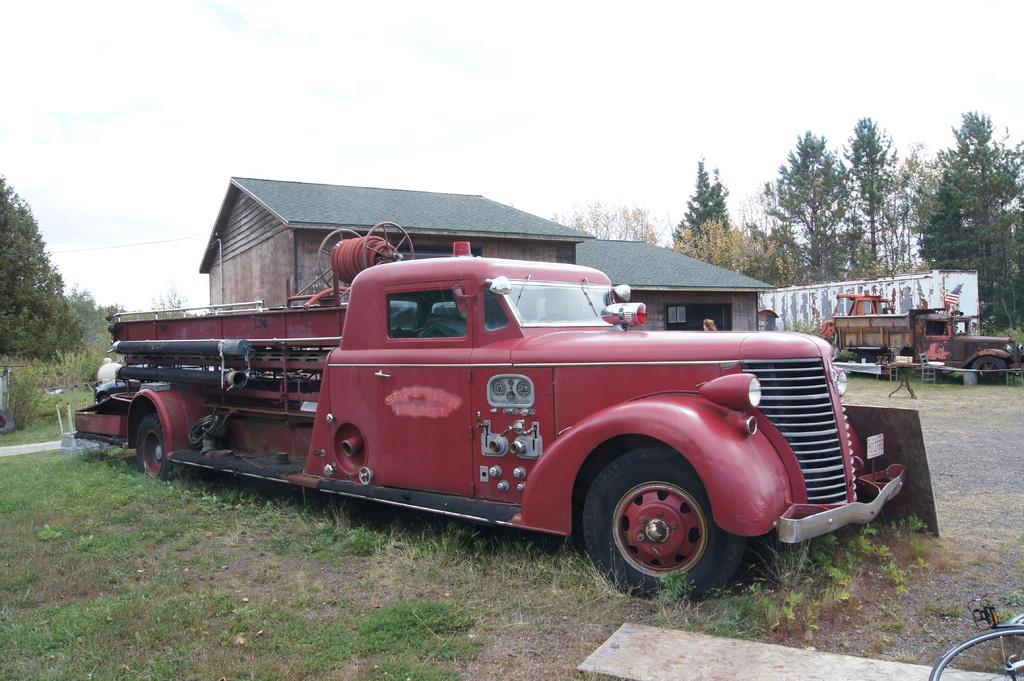Can you describe this image briefly? In the picture there is a vehicle and behind the vehicle there is a house and beside the house there are two damaged vehicles and around the house there are plenty of trees. 